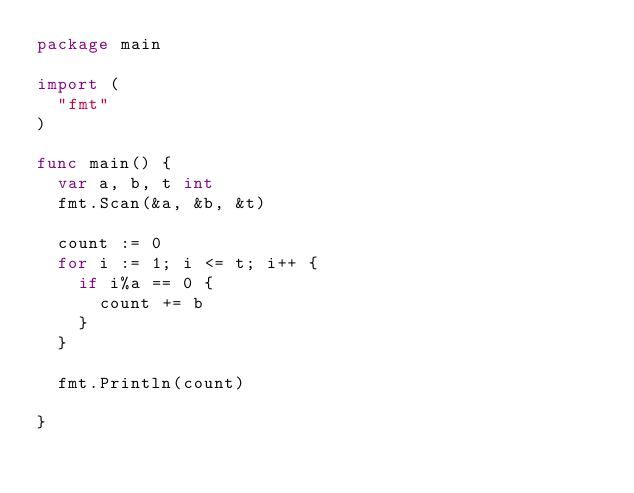<code> <loc_0><loc_0><loc_500><loc_500><_Go_>package main

import (
	"fmt"
)

func main() {
	var a, b, t int
	fmt.Scan(&a, &b, &t)

	count := 0
	for i := 1; i <= t; i++ {
		if i%a == 0 {
			count += b
		}
	}

	fmt.Println(count)

}
</code> 